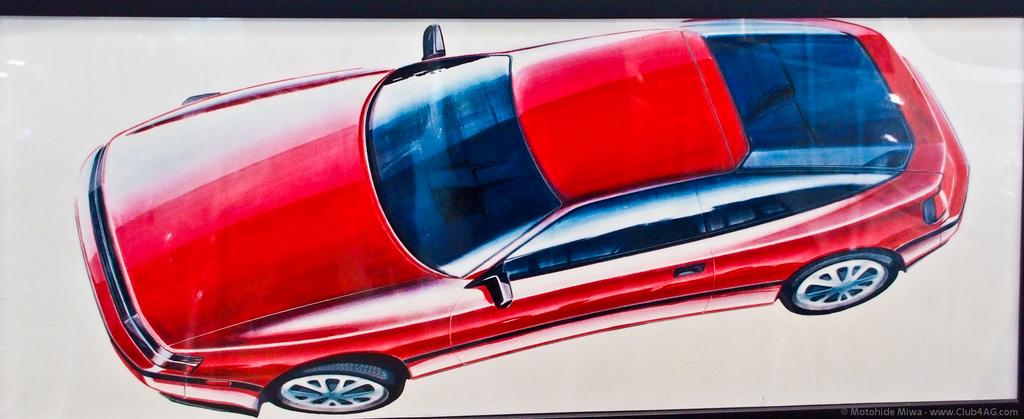What is present in the image that features a specific subject or object? There is a poster in the image. What is depicted on the poster? The poster features a car. Where is the shelf located in the image? There is no shelf present in the image. How many geese are visible in the image? There are no geese present in the image. 